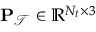Convert formula to latex. <formula><loc_0><loc_0><loc_500><loc_500>P _ { \mathcal { T } } \in \mathbb { R } ^ { N _ { t } \times 3 }</formula> 